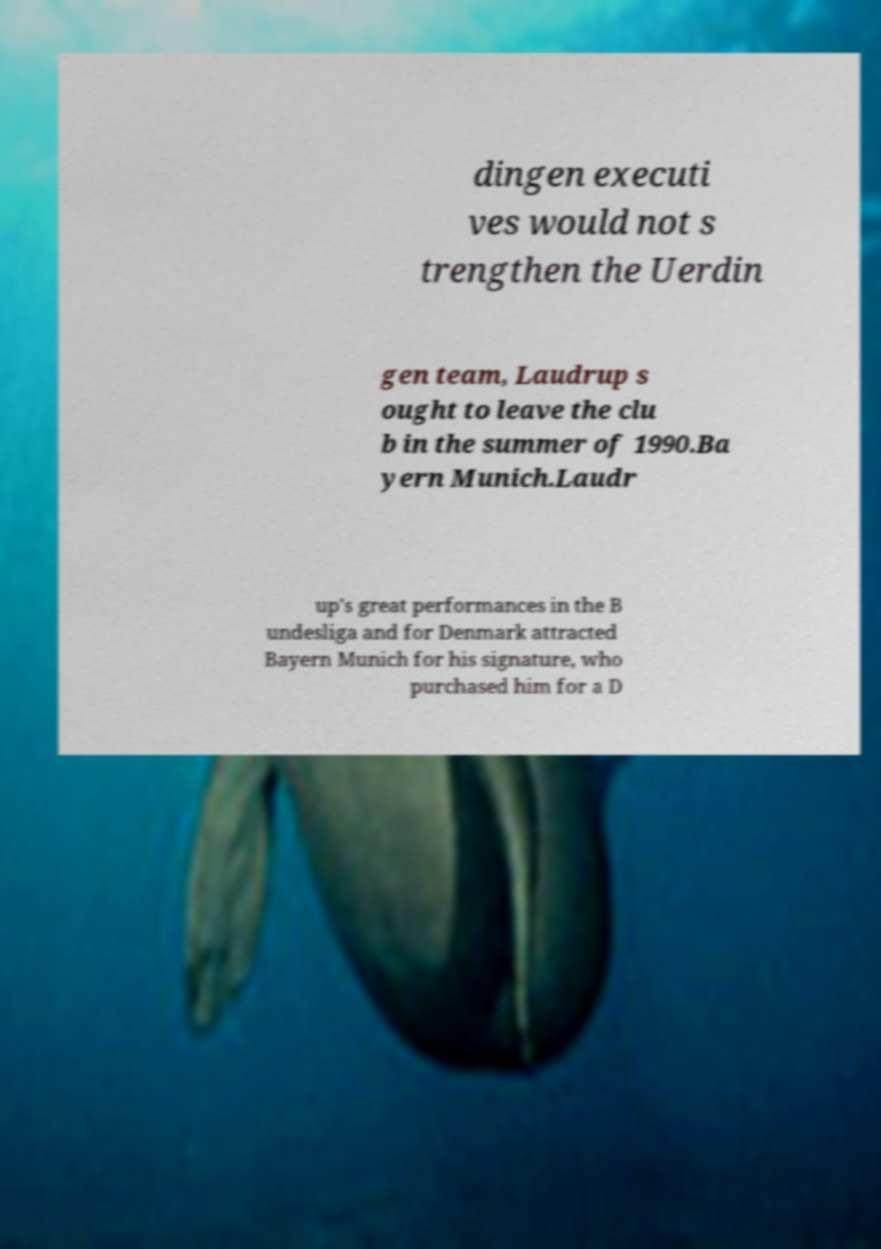There's text embedded in this image that I need extracted. Can you transcribe it verbatim? dingen executi ves would not s trengthen the Uerdin gen team, Laudrup s ought to leave the clu b in the summer of 1990.Ba yern Munich.Laudr up's great performances in the B undesliga and for Denmark attracted Bayern Munich for his signature, who purchased him for a D 